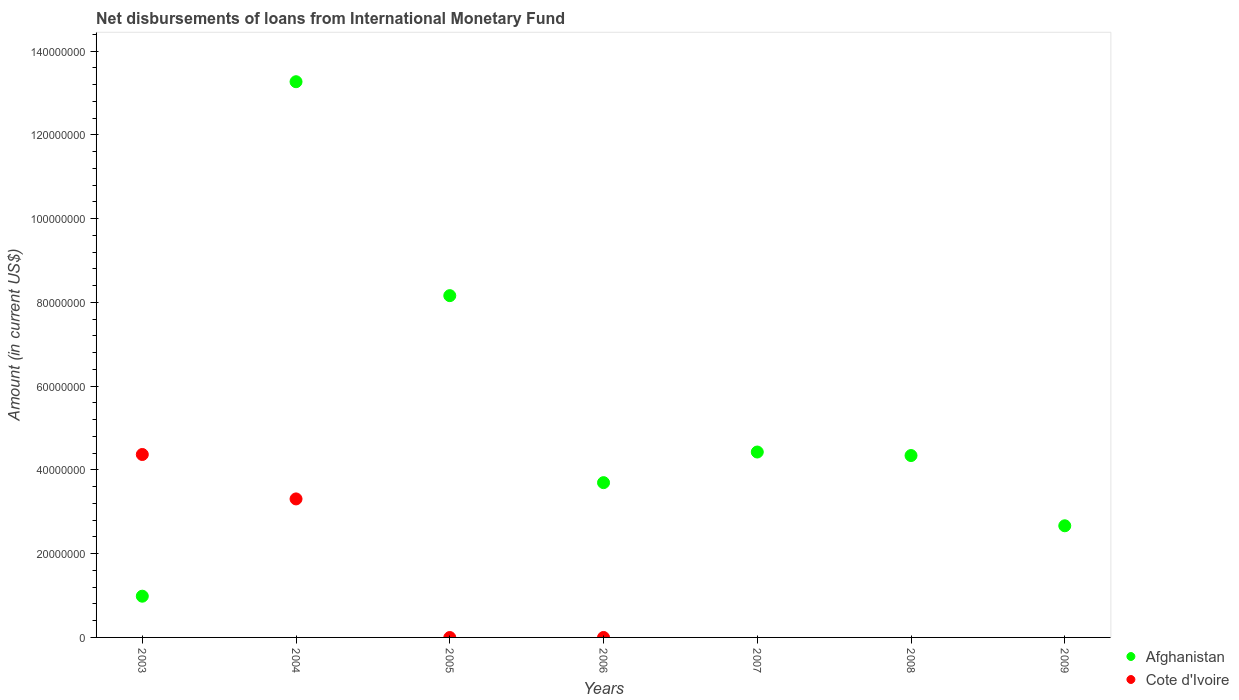What is the amount of loans disbursed in Cote d'Ivoire in 2005?
Keep it short and to the point. 0. Across all years, what is the maximum amount of loans disbursed in Afghanistan?
Your answer should be compact. 1.33e+08. Across all years, what is the minimum amount of loans disbursed in Cote d'Ivoire?
Your response must be concise. 0. What is the total amount of loans disbursed in Cote d'Ivoire in the graph?
Your response must be concise. 7.68e+07. What is the difference between the amount of loans disbursed in Afghanistan in 2003 and that in 2005?
Your answer should be very brief. -7.18e+07. What is the difference between the amount of loans disbursed in Cote d'Ivoire in 2004 and the amount of loans disbursed in Afghanistan in 2009?
Make the answer very short. 6.42e+06. What is the average amount of loans disbursed in Afghanistan per year?
Keep it short and to the point. 5.36e+07. In the year 2003, what is the difference between the amount of loans disbursed in Cote d'Ivoire and amount of loans disbursed in Afghanistan?
Your answer should be very brief. 3.38e+07. What is the ratio of the amount of loans disbursed in Afghanistan in 2003 to that in 2005?
Your answer should be very brief. 0.12. What is the difference between the highest and the second highest amount of loans disbursed in Afghanistan?
Provide a succinct answer. 5.11e+07. What is the difference between the highest and the lowest amount of loans disbursed in Cote d'Ivoire?
Offer a terse response. 4.37e+07. Does the amount of loans disbursed in Cote d'Ivoire monotonically increase over the years?
Give a very brief answer. No. Is the amount of loans disbursed in Afghanistan strictly less than the amount of loans disbursed in Cote d'Ivoire over the years?
Your answer should be very brief. No. How many dotlines are there?
Provide a short and direct response. 2. What is the difference between two consecutive major ticks on the Y-axis?
Your response must be concise. 2.00e+07. Does the graph contain any zero values?
Offer a terse response. Yes. Does the graph contain grids?
Ensure brevity in your answer.  No. How many legend labels are there?
Make the answer very short. 2. What is the title of the graph?
Ensure brevity in your answer.  Net disbursements of loans from International Monetary Fund. What is the Amount (in current US$) in Afghanistan in 2003?
Offer a very short reply. 9.84e+06. What is the Amount (in current US$) of Cote d'Ivoire in 2003?
Make the answer very short. 4.37e+07. What is the Amount (in current US$) in Afghanistan in 2004?
Ensure brevity in your answer.  1.33e+08. What is the Amount (in current US$) in Cote d'Ivoire in 2004?
Give a very brief answer. 3.31e+07. What is the Amount (in current US$) of Afghanistan in 2005?
Your response must be concise. 8.16e+07. What is the Amount (in current US$) of Cote d'Ivoire in 2005?
Your answer should be compact. 0. What is the Amount (in current US$) in Afghanistan in 2006?
Offer a terse response. 3.70e+07. What is the Amount (in current US$) of Cote d'Ivoire in 2006?
Your answer should be very brief. 0. What is the Amount (in current US$) of Afghanistan in 2007?
Provide a succinct answer. 4.43e+07. What is the Amount (in current US$) in Cote d'Ivoire in 2007?
Provide a succinct answer. 0. What is the Amount (in current US$) of Afghanistan in 2008?
Your response must be concise. 4.34e+07. What is the Amount (in current US$) of Cote d'Ivoire in 2008?
Provide a succinct answer. 0. What is the Amount (in current US$) of Afghanistan in 2009?
Offer a terse response. 2.67e+07. What is the Amount (in current US$) in Cote d'Ivoire in 2009?
Offer a terse response. 0. Across all years, what is the maximum Amount (in current US$) in Afghanistan?
Keep it short and to the point. 1.33e+08. Across all years, what is the maximum Amount (in current US$) of Cote d'Ivoire?
Your answer should be very brief. 4.37e+07. Across all years, what is the minimum Amount (in current US$) in Afghanistan?
Ensure brevity in your answer.  9.84e+06. What is the total Amount (in current US$) in Afghanistan in the graph?
Ensure brevity in your answer.  3.75e+08. What is the total Amount (in current US$) in Cote d'Ivoire in the graph?
Ensure brevity in your answer.  7.68e+07. What is the difference between the Amount (in current US$) in Afghanistan in 2003 and that in 2004?
Provide a short and direct response. -1.23e+08. What is the difference between the Amount (in current US$) of Cote d'Ivoire in 2003 and that in 2004?
Provide a succinct answer. 1.06e+07. What is the difference between the Amount (in current US$) in Afghanistan in 2003 and that in 2005?
Your answer should be very brief. -7.18e+07. What is the difference between the Amount (in current US$) of Afghanistan in 2003 and that in 2006?
Your answer should be compact. -2.71e+07. What is the difference between the Amount (in current US$) of Afghanistan in 2003 and that in 2007?
Offer a very short reply. -3.44e+07. What is the difference between the Amount (in current US$) of Afghanistan in 2003 and that in 2008?
Provide a succinct answer. -3.36e+07. What is the difference between the Amount (in current US$) in Afghanistan in 2003 and that in 2009?
Offer a terse response. -1.68e+07. What is the difference between the Amount (in current US$) of Afghanistan in 2004 and that in 2005?
Keep it short and to the point. 5.11e+07. What is the difference between the Amount (in current US$) of Afghanistan in 2004 and that in 2006?
Your response must be concise. 9.57e+07. What is the difference between the Amount (in current US$) in Afghanistan in 2004 and that in 2007?
Provide a short and direct response. 8.84e+07. What is the difference between the Amount (in current US$) in Afghanistan in 2004 and that in 2008?
Make the answer very short. 8.93e+07. What is the difference between the Amount (in current US$) of Afghanistan in 2004 and that in 2009?
Provide a succinct answer. 1.06e+08. What is the difference between the Amount (in current US$) of Afghanistan in 2005 and that in 2006?
Your answer should be very brief. 4.47e+07. What is the difference between the Amount (in current US$) in Afghanistan in 2005 and that in 2007?
Your response must be concise. 3.73e+07. What is the difference between the Amount (in current US$) of Afghanistan in 2005 and that in 2008?
Offer a terse response. 3.82e+07. What is the difference between the Amount (in current US$) in Afghanistan in 2005 and that in 2009?
Ensure brevity in your answer.  5.50e+07. What is the difference between the Amount (in current US$) of Afghanistan in 2006 and that in 2007?
Your answer should be very brief. -7.31e+06. What is the difference between the Amount (in current US$) in Afghanistan in 2006 and that in 2008?
Ensure brevity in your answer.  -6.47e+06. What is the difference between the Amount (in current US$) in Afghanistan in 2006 and that in 2009?
Offer a terse response. 1.03e+07. What is the difference between the Amount (in current US$) of Afghanistan in 2007 and that in 2008?
Give a very brief answer. 8.41e+05. What is the difference between the Amount (in current US$) of Afghanistan in 2007 and that in 2009?
Ensure brevity in your answer.  1.76e+07. What is the difference between the Amount (in current US$) in Afghanistan in 2008 and that in 2009?
Provide a short and direct response. 1.68e+07. What is the difference between the Amount (in current US$) in Afghanistan in 2003 and the Amount (in current US$) in Cote d'Ivoire in 2004?
Keep it short and to the point. -2.32e+07. What is the average Amount (in current US$) of Afghanistan per year?
Keep it short and to the point. 5.36e+07. What is the average Amount (in current US$) in Cote d'Ivoire per year?
Your response must be concise. 1.10e+07. In the year 2003, what is the difference between the Amount (in current US$) in Afghanistan and Amount (in current US$) in Cote d'Ivoire?
Your answer should be very brief. -3.38e+07. In the year 2004, what is the difference between the Amount (in current US$) in Afghanistan and Amount (in current US$) in Cote d'Ivoire?
Keep it short and to the point. 9.96e+07. What is the ratio of the Amount (in current US$) of Afghanistan in 2003 to that in 2004?
Your answer should be compact. 0.07. What is the ratio of the Amount (in current US$) in Cote d'Ivoire in 2003 to that in 2004?
Give a very brief answer. 1.32. What is the ratio of the Amount (in current US$) of Afghanistan in 2003 to that in 2005?
Your answer should be compact. 0.12. What is the ratio of the Amount (in current US$) in Afghanistan in 2003 to that in 2006?
Ensure brevity in your answer.  0.27. What is the ratio of the Amount (in current US$) of Afghanistan in 2003 to that in 2007?
Offer a very short reply. 0.22. What is the ratio of the Amount (in current US$) of Afghanistan in 2003 to that in 2008?
Offer a terse response. 0.23. What is the ratio of the Amount (in current US$) in Afghanistan in 2003 to that in 2009?
Offer a terse response. 0.37. What is the ratio of the Amount (in current US$) of Afghanistan in 2004 to that in 2005?
Ensure brevity in your answer.  1.63. What is the ratio of the Amount (in current US$) in Afghanistan in 2004 to that in 2006?
Your response must be concise. 3.59. What is the ratio of the Amount (in current US$) of Afghanistan in 2004 to that in 2007?
Your answer should be compact. 3. What is the ratio of the Amount (in current US$) in Afghanistan in 2004 to that in 2008?
Provide a short and direct response. 3.06. What is the ratio of the Amount (in current US$) of Afghanistan in 2004 to that in 2009?
Your answer should be very brief. 4.98. What is the ratio of the Amount (in current US$) of Afghanistan in 2005 to that in 2006?
Provide a succinct answer. 2.21. What is the ratio of the Amount (in current US$) in Afghanistan in 2005 to that in 2007?
Your answer should be very brief. 1.84. What is the ratio of the Amount (in current US$) in Afghanistan in 2005 to that in 2008?
Ensure brevity in your answer.  1.88. What is the ratio of the Amount (in current US$) in Afghanistan in 2005 to that in 2009?
Ensure brevity in your answer.  3.06. What is the ratio of the Amount (in current US$) of Afghanistan in 2006 to that in 2007?
Keep it short and to the point. 0.83. What is the ratio of the Amount (in current US$) of Afghanistan in 2006 to that in 2008?
Make the answer very short. 0.85. What is the ratio of the Amount (in current US$) in Afghanistan in 2006 to that in 2009?
Make the answer very short. 1.39. What is the ratio of the Amount (in current US$) of Afghanistan in 2007 to that in 2008?
Give a very brief answer. 1.02. What is the ratio of the Amount (in current US$) in Afghanistan in 2007 to that in 2009?
Your answer should be very brief. 1.66. What is the ratio of the Amount (in current US$) of Afghanistan in 2008 to that in 2009?
Your response must be concise. 1.63. What is the difference between the highest and the second highest Amount (in current US$) in Afghanistan?
Provide a succinct answer. 5.11e+07. What is the difference between the highest and the lowest Amount (in current US$) of Afghanistan?
Offer a very short reply. 1.23e+08. What is the difference between the highest and the lowest Amount (in current US$) in Cote d'Ivoire?
Your answer should be very brief. 4.37e+07. 